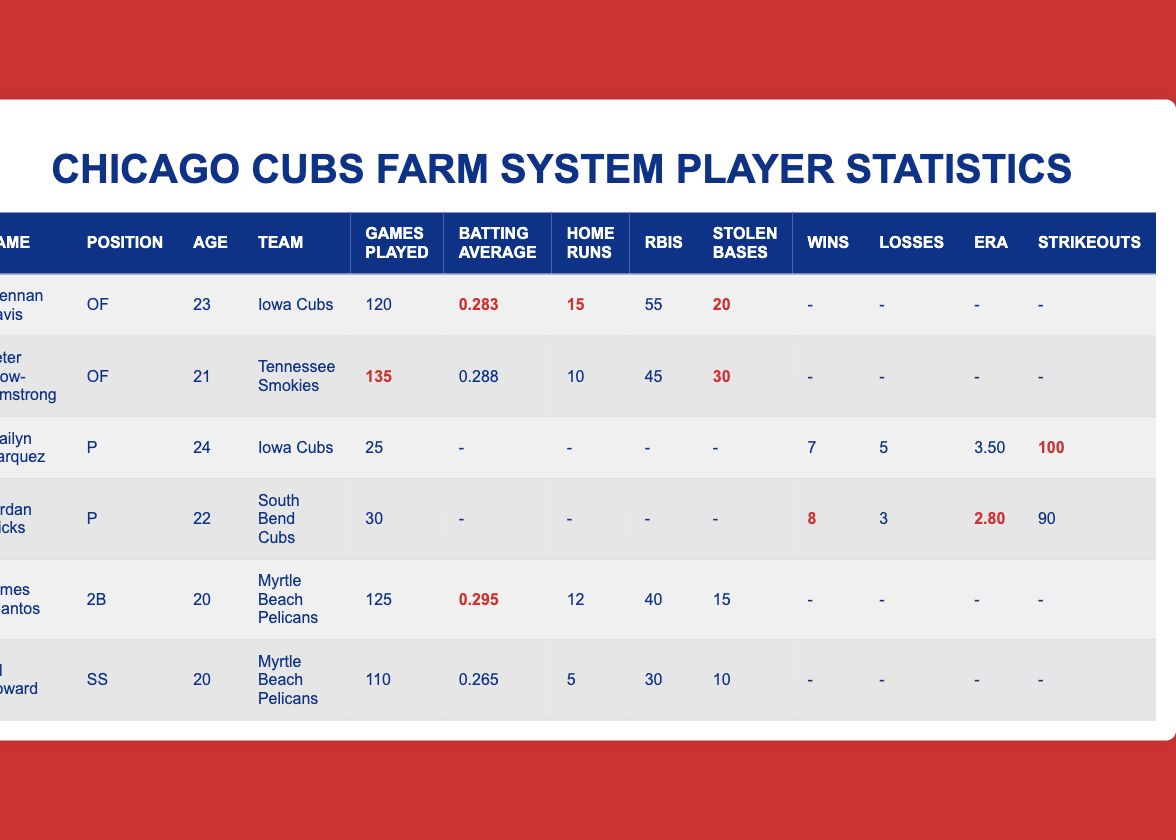What is the batting average of Brennan Davis? The table shows that Brennan Davis has a batting average highlighted as 0.283.
Answer: 0.283 How many home runs did Peter Crow-Armstrong hit? The table indicates that Peter Crow-Armstrong hit a total of 10 home runs, as seen in the highlighted row for his statistics.
Answer: 10 Who has the highest batting average among the listed players? By comparing the batting averages: 0.283 (Brennan Davis), 0.288 (Peter Crow-Armstrong), 0.295 (James Triantos), and 0.265 (Ed Howard), James Triantos has the highest average at 0.295.
Answer: James Triantos What is the total number of runs batted in (RBIs) for all players listed? Adding the RBIs from each player: 55 (Brennan Davis) + 45 (Peter Crow-Armstrong) + 40 (James Triantos) + 30 (Ed Howard) = 170. The pitchers do not contribute to RBIs.
Answer: 170 How many stolen bases did Jordan Wicks achieve? The table shows that Jordan Wicks has not recorded any stolen bases, indicated by a dash in the stolen bases column.
Answer: 0 Is Ed Howard younger than Peter Crow-Armstrong? Ed Howard is 20 years old while Peter Crow-Armstrong is 21 years old, so Ed Howard is younger.
Answer: Yes What is the difference in ERA between Jordan Wicks and Brailyn Marquez? The ERA for Jordan Wicks is 2.80 and for Brailyn Marquez, it is 3.50. The difference is 3.50 - 2.80 = 0.70.
Answer: 0.70 What is the average number of home runs hit by the five non-pitching players? The home runs for the non-pitching players are: 15 (Brennan Davis), 10 (Peter Crow-Armstrong), 12 (James Triantos), and 5 (Ed Howard). The sum is 15 + 10 + 12 + 5 = 52. There are 4 players, so the average is 52/4 = 13.
Answer: 13 Which player played the most games? The table shows that Peter Crow-Armstrong played the most games at 135, indicated by the highlighted value in the games played column.
Answer: Peter Crow-Armstrong What is the combined total of wins and losses for Brailyn Marquez? Brailyn Marquez has 7 wins and 5 losses. Combining these gives 7 + 5 = 12.
Answer: 12 Which player has the most stolen bases? Comparing the stolen bases column: Brennan Davis has 20, Peter Crow-Armstrong has 30, James Triantos has 15, and Ed Howard has 10. Peter Crow-Armstrong has the most with 30 stolen bases.
Answer: Peter Crow-Armstrong 